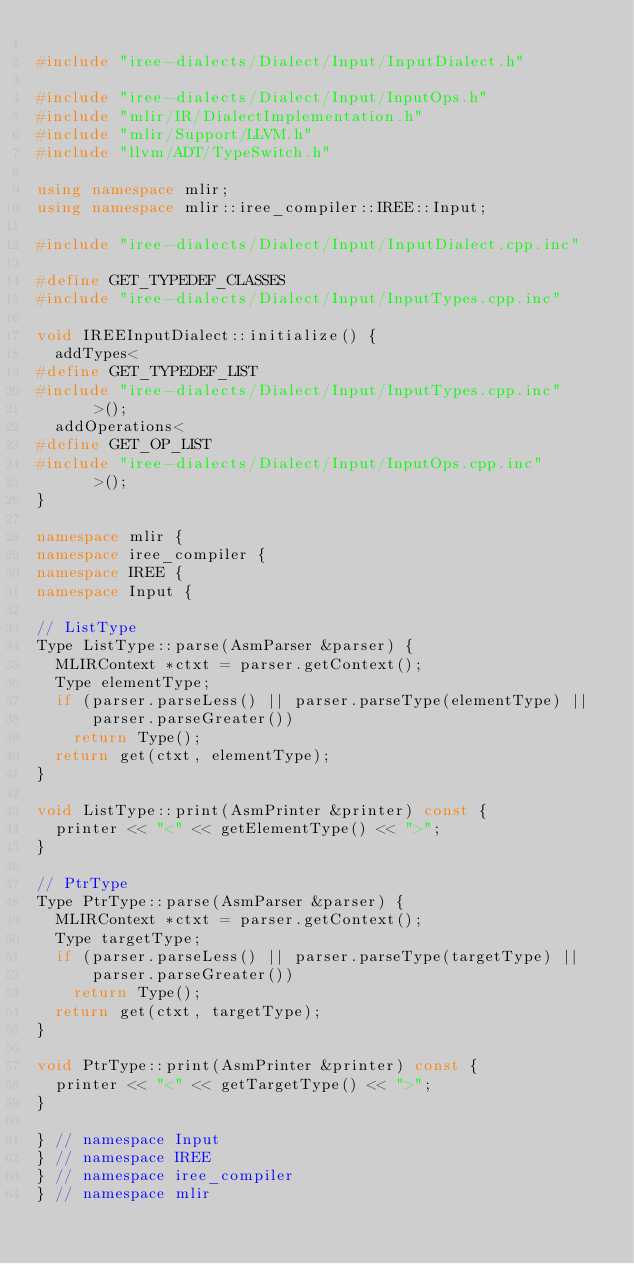Convert code to text. <code><loc_0><loc_0><loc_500><loc_500><_C++_>
#include "iree-dialects/Dialect/Input/InputDialect.h"

#include "iree-dialects/Dialect/Input/InputOps.h"
#include "mlir/IR/DialectImplementation.h"
#include "mlir/Support/LLVM.h"
#include "llvm/ADT/TypeSwitch.h"

using namespace mlir;
using namespace mlir::iree_compiler::IREE::Input;

#include "iree-dialects/Dialect/Input/InputDialect.cpp.inc"

#define GET_TYPEDEF_CLASSES
#include "iree-dialects/Dialect/Input/InputTypes.cpp.inc"

void IREEInputDialect::initialize() {
  addTypes<
#define GET_TYPEDEF_LIST
#include "iree-dialects/Dialect/Input/InputTypes.cpp.inc"
      >();
  addOperations<
#define GET_OP_LIST
#include "iree-dialects/Dialect/Input/InputOps.cpp.inc"
      >();
}

namespace mlir {
namespace iree_compiler {
namespace IREE {
namespace Input {

// ListType
Type ListType::parse(AsmParser &parser) {
  MLIRContext *ctxt = parser.getContext();
  Type elementType;
  if (parser.parseLess() || parser.parseType(elementType) ||
      parser.parseGreater())
    return Type();
  return get(ctxt, elementType);
}

void ListType::print(AsmPrinter &printer) const {
  printer << "<" << getElementType() << ">";
}

// PtrType
Type PtrType::parse(AsmParser &parser) {
  MLIRContext *ctxt = parser.getContext();
  Type targetType;
  if (parser.parseLess() || parser.parseType(targetType) ||
      parser.parseGreater())
    return Type();
  return get(ctxt, targetType);
}

void PtrType::print(AsmPrinter &printer) const {
  printer << "<" << getTargetType() << ">";
}

} // namespace Input
} // namespace IREE
} // namespace iree_compiler
} // namespace mlir
</code> 